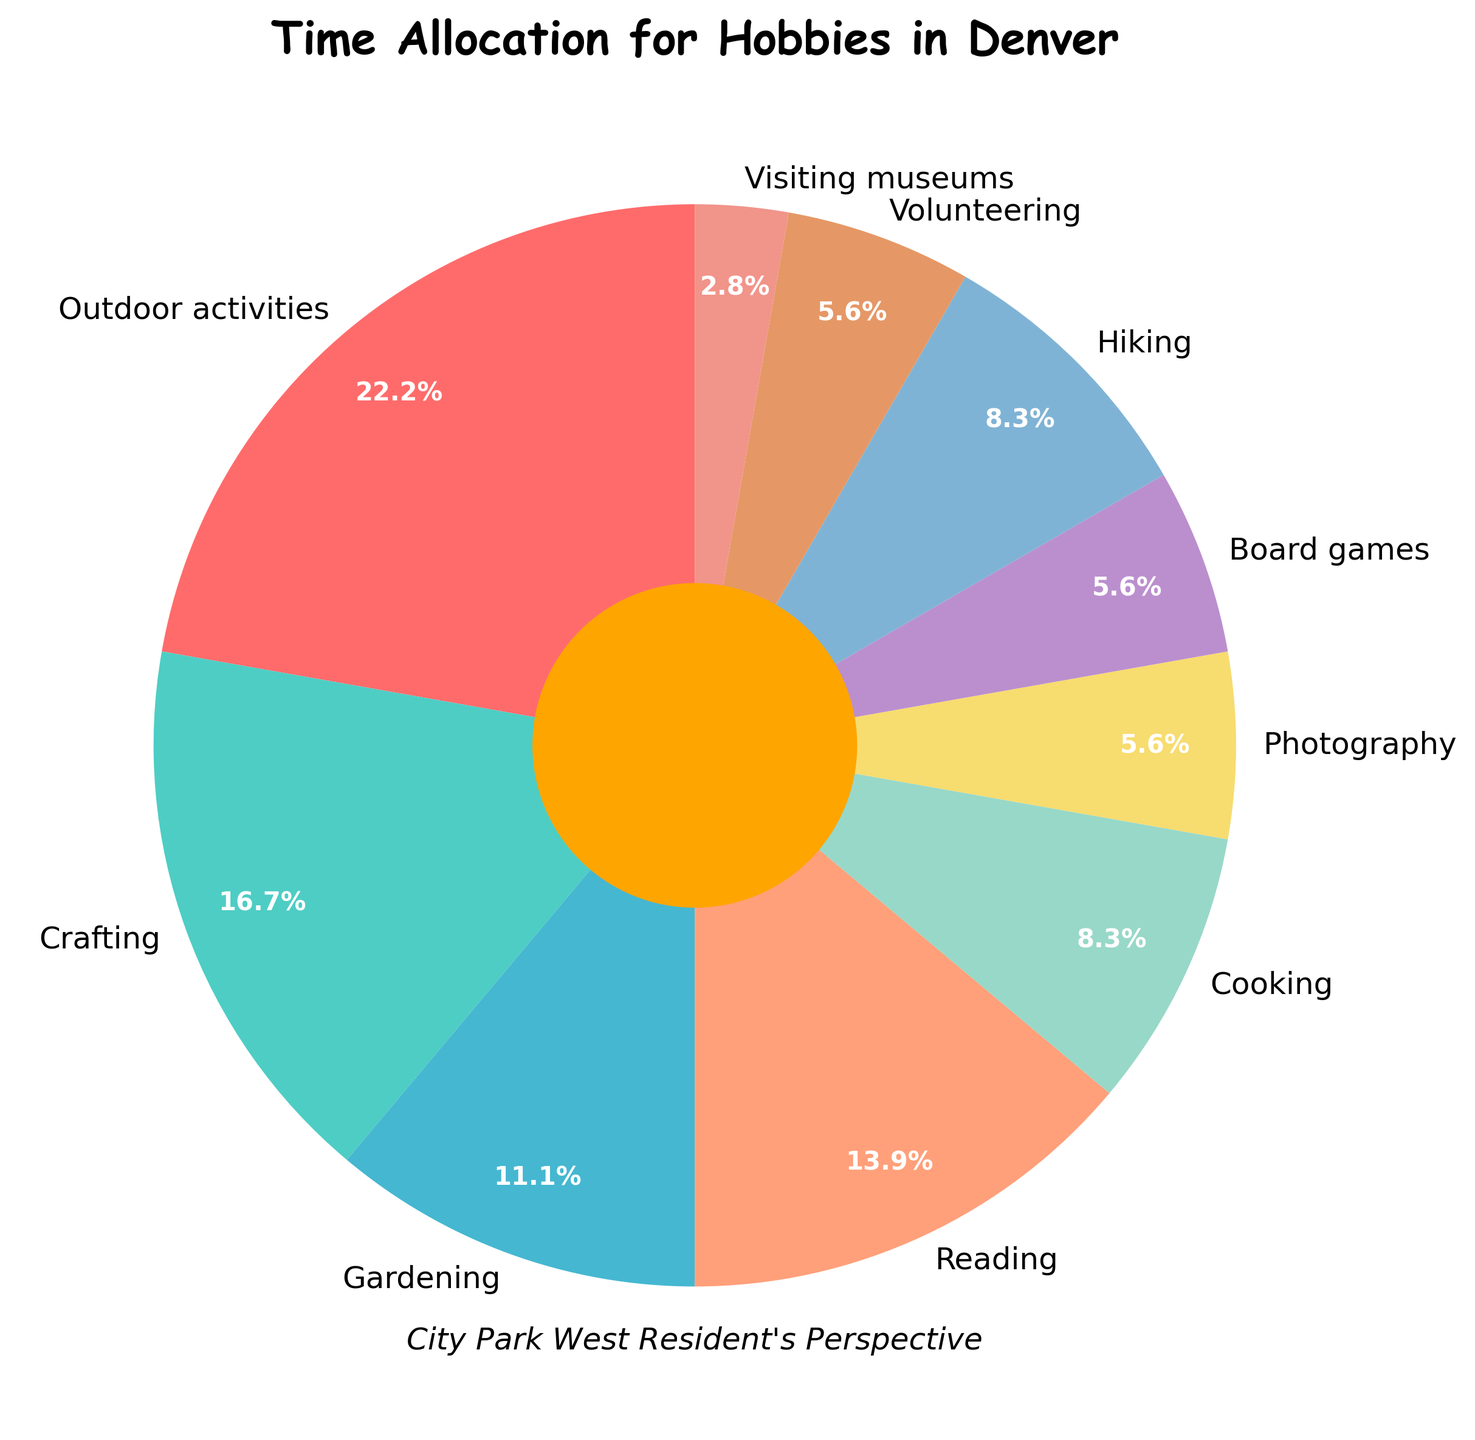What percentage of time do Denver residents allocate to outdoor activities? In the pie chart, outdoor activities are labeled, and the percentage allocation can be seen directly on the chart. It shows 8 hours per week, which is 22.2%.
Answer: 22.2% How much more time do Denver residents spend on crafting compared to cooking per week? Crafting is allocated 6 hours per week, while cooking is allocated 3 hours per week. The difference is 6 - 3 = 3 hours.
Answer: 3 hours Which hobby has the smallest time allocation, and what percentage does it represent? The pie chart shows that visiting museums has the smallest time allocation with 1 hour per week, which represents 2.8% of the total time.
Answer: Visiting museums, 2.8% What is the combined time allocation for hiking and gardening? Hiking is allocated 3 hours per week, and gardening is allocated 4 hours per week. The combined time is 3 + 4 = 7 hours per week.
Answer: 7 hours per week Are there any hobbies that have the same time allocation? If so, which ones and how many hours do they have? Photography, board games, and volunteering each have 2 hours per week, as indicated in the pie chart.
Answer: Photography, board games, volunteering; 2 hours per week each Which hobby has the second highest time allocation, and how many hours per week is it? On the pie chart, crafting shows the second highest allocation with 6 hours per week.
Answer: Crafting, 6 hours per week How much more time do Denver residents spend on outdoor activities compared to reading? Outdoor activities are allocated 8 hours per week, and reading is allocated 5 hours per week. The difference is 8 - 5 = 3 hours.
Answer: 3 hours What is the visual attribute used to differentiate between the various hobbies on the pie chart? The pie chart uses different colors to visually differentiate between the hobbies.
Answer: Different colors What is the total time allocated to all the hobbies listed on the chart? Add all the hours per week for each hobby: 8 + 6 + 4 + 5 + 3 + 2 + 2 + 3 + 2 + 1 = 36 hours per week.
Answer: 36 hours per week 